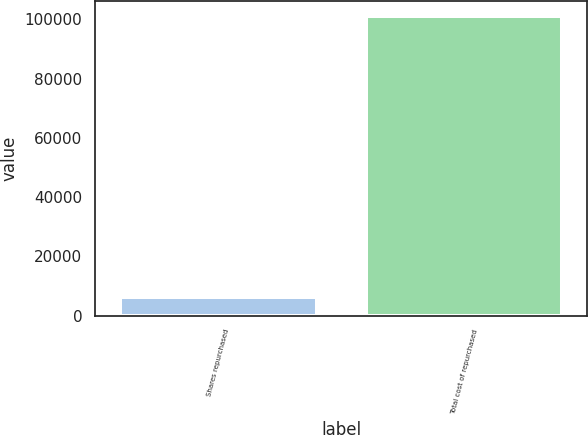<chart> <loc_0><loc_0><loc_500><loc_500><bar_chart><fcel>Shares repurchased<fcel>Total cost of repurchased<nl><fcel>6150<fcel>101070<nl></chart> 